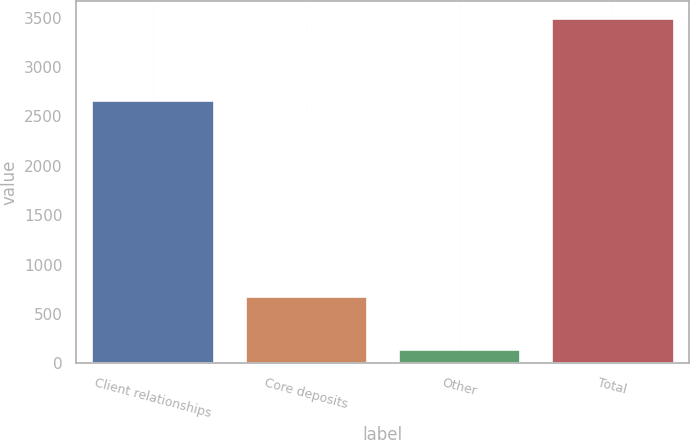Convert chart to OTSL. <chart><loc_0><loc_0><loc_500><loc_500><bar_chart><fcel>Client relationships<fcel>Core deposits<fcel>Other<fcel>Total<nl><fcel>2669<fcel>686<fcel>142<fcel>3497<nl></chart> 